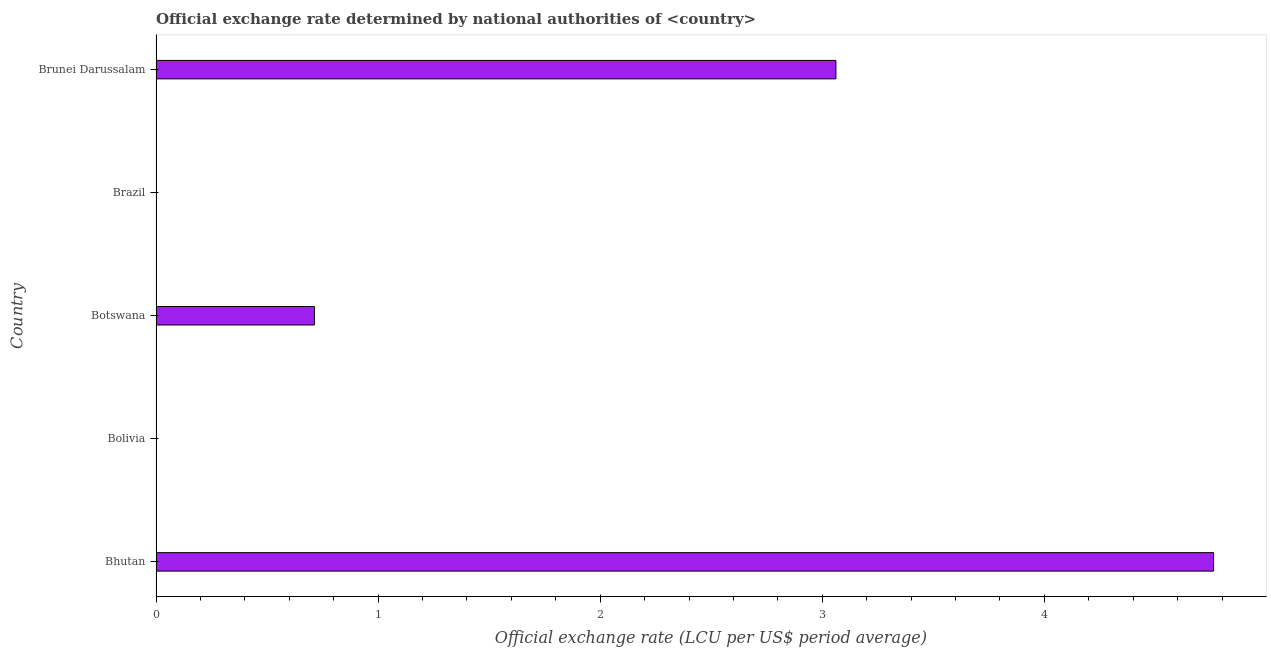What is the title of the graph?
Provide a succinct answer. Official exchange rate determined by national authorities of <country>. What is the label or title of the X-axis?
Your answer should be compact. Official exchange rate (LCU per US$ period average). What is the official exchange rate in Brunei Darussalam?
Give a very brief answer. 3.06. Across all countries, what is the maximum official exchange rate?
Your answer should be compact. 4.76. Across all countries, what is the minimum official exchange rate?
Offer a very short reply. 1.67764155487091e-13. In which country was the official exchange rate maximum?
Provide a succinct answer. Bhutan. In which country was the official exchange rate minimum?
Your response must be concise. Brazil. What is the sum of the official exchange rate?
Give a very brief answer. 8.54. What is the difference between the official exchange rate in Bolivia and Brazil?
Your answer should be very brief. 0. What is the average official exchange rate per country?
Make the answer very short. 1.71. What is the median official exchange rate?
Offer a terse response. 0.71. In how many countries, is the official exchange rate greater than 4.4 ?
Give a very brief answer. 1. What is the ratio of the official exchange rate in Bolivia to that in Brazil?
Your response must be concise. 7.08e+07. Is the difference between the official exchange rate in Brazil and Brunei Darussalam greater than the difference between any two countries?
Keep it short and to the point. No. What is the difference between the highest and the second highest official exchange rate?
Ensure brevity in your answer.  1.7. Is the sum of the official exchange rate in Bhutan and Brazil greater than the maximum official exchange rate across all countries?
Give a very brief answer. Yes. What is the difference between the highest and the lowest official exchange rate?
Give a very brief answer. 4.76. In how many countries, is the official exchange rate greater than the average official exchange rate taken over all countries?
Offer a very short reply. 2. How many bars are there?
Your answer should be compact. 5. Are all the bars in the graph horizontal?
Ensure brevity in your answer.  Yes. How many countries are there in the graph?
Provide a succinct answer. 5. What is the Official exchange rate (LCU per US$ period average) of Bhutan?
Offer a very short reply. 4.76. What is the Official exchange rate (LCU per US$ period average) of Bolivia?
Your answer should be compact. 1.188e-5. What is the Official exchange rate (LCU per US$ period average) in Botswana?
Make the answer very short. 0.71. What is the Official exchange rate (LCU per US$ period average) in Brazil?
Provide a succinct answer. 1.67764155487091e-13. What is the Official exchange rate (LCU per US$ period average) in Brunei Darussalam?
Give a very brief answer. 3.06. What is the difference between the Official exchange rate (LCU per US$ period average) in Bhutan and Bolivia?
Make the answer very short. 4.76. What is the difference between the Official exchange rate (LCU per US$ period average) in Bhutan and Botswana?
Give a very brief answer. 4.05. What is the difference between the Official exchange rate (LCU per US$ period average) in Bhutan and Brazil?
Your answer should be very brief. 4.76. What is the difference between the Official exchange rate (LCU per US$ period average) in Bhutan and Brunei Darussalam?
Offer a very short reply. 1.7. What is the difference between the Official exchange rate (LCU per US$ period average) in Bolivia and Botswana?
Provide a short and direct response. -0.71. What is the difference between the Official exchange rate (LCU per US$ period average) in Bolivia and Brazil?
Offer a terse response. 1e-5. What is the difference between the Official exchange rate (LCU per US$ period average) in Bolivia and Brunei Darussalam?
Give a very brief answer. -3.06. What is the difference between the Official exchange rate (LCU per US$ period average) in Botswana and Brazil?
Offer a very short reply. 0.71. What is the difference between the Official exchange rate (LCU per US$ period average) in Botswana and Brunei Darussalam?
Your answer should be compact. -2.35. What is the difference between the Official exchange rate (LCU per US$ period average) in Brazil and Brunei Darussalam?
Offer a very short reply. -3.06. What is the ratio of the Official exchange rate (LCU per US$ period average) in Bhutan to that in Bolivia?
Offer a very short reply. 4.01e+05. What is the ratio of the Official exchange rate (LCU per US$ period average) in Bhutan to that in Botswana?
Keep it short and to the point. 6.68. What is the ratio of the Official exchange rate (LCU per US$ period average) in Bhutan to that in Brazil?
Provide a succinct answer. 2.84e+13. What is the ratio of the Official exchange rate (LCU per US$ period average) in Bhutan to that in Brunei Darussalam?
Your answer should be very brief. 1.56. What is the ratio of the Official exchange rate (LCU per US$ period average) in Bolivia to that in Botswana?
Your answer should be compact. 0. What is the ratio of the Official exchange rate (LCU per US$ period average) in Bolivia to that in Brazil?
Give a very brief answer. 7.08e+07. What is the ratio of the Official exchange rate (LCU per US$ period average) in Botswana to that in Brazil?
Make the answer very short. 4.25e+12. What is the ratio of the Official exchange rate (LCU per US$ period average) in Botswana to that in Brunei Darussalam?
Your answer should be very brief. 0.23. 